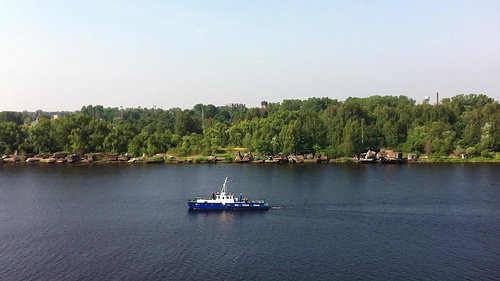Please provide a short description for this region: [0.39, 0.55, 0.48, 0.61]. The white mast of the ship stands out against the background, possibly made of sturdy material given its appearance. 